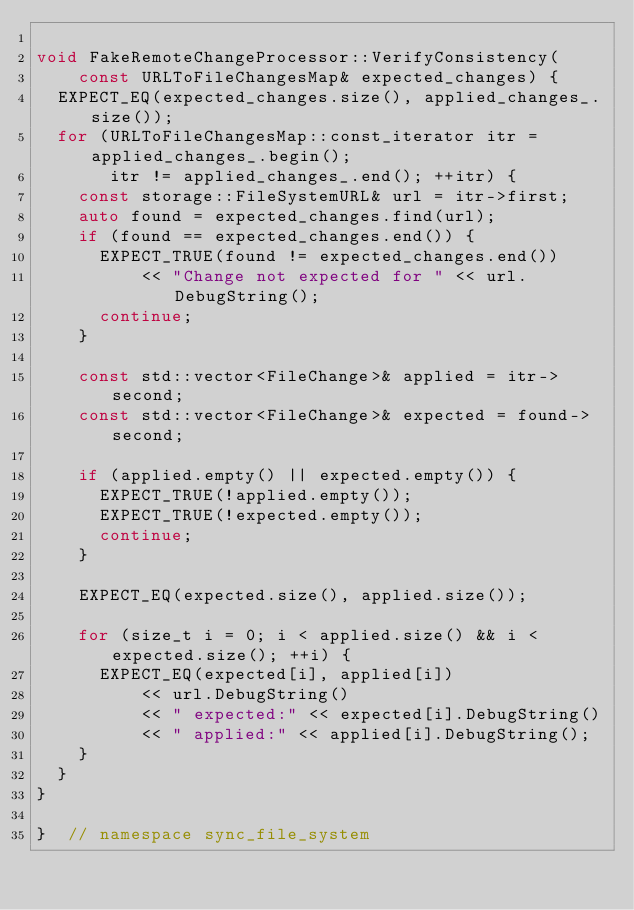<code> <loc_0><loc_0><loc_500><loc_500><_C++_>
void FakeRemoteChangeProcessor::VerifyConsistency(
    const URLToFileChangesMap& expected_changes) {
  EXPECT_EQ(expected_changes.size(), applied_changes_.size());
  for (URLToFileChangesMap::const_iterator itr = applied_changes_.begin();
       itr != applied_changes_.end(); ++itr) {
    const storage::FileSystemURL& url = itr->first;
    auto found = expected_changes.find(url);
    if (found == expected_changes.end()) {
      EXPECT_TRUE(found != expected_changes.end())
          << "Change not expected for " << url.DebugString();
      continue;
    }

    const std::vector<FileChange>& applied = itr->second;
    const std::vector<FileChange>& expected = found->second;

    if (applied.empty() || expected.empty()) {
      EXPECT_TRUE(!applied.empty());
      EXPECT_TRUE(!expected.empty());
      continue;
    }

    EXPECT_EQ(expected.size(), applied.size());

    for (size_t i = 0; i < applied.size() && i < expected.size(); ++i) {
      EXPECT_EQ(expected[i], applied[i])
          << url.DebugString()
          << " expected:" << expected[i].DebugString()
          << " applied:" << applied[i].DebugString();
    }
  }
}

}  // namespace sync_file_system
</code> 